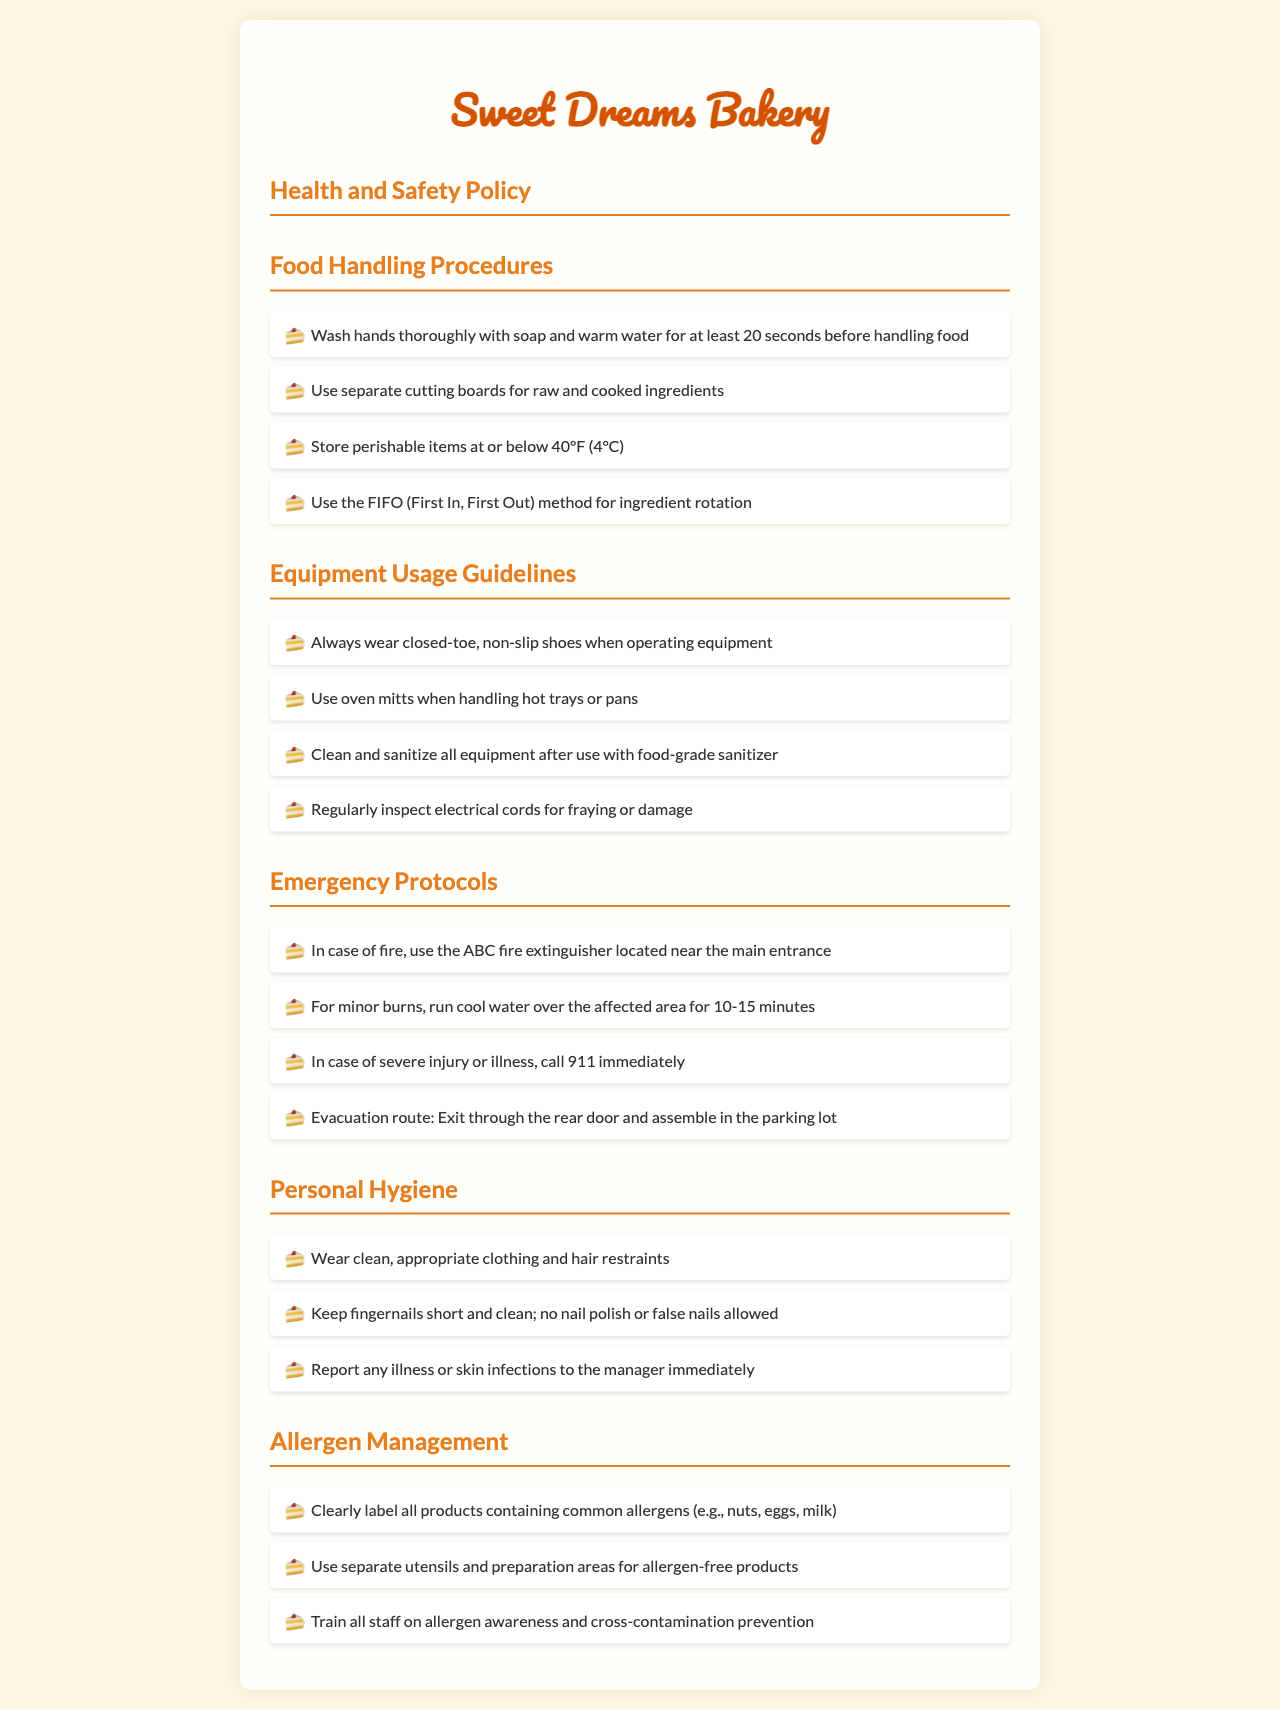what is the first step in food handling procedures? The document states that the first step in food handling procedures is to wash hands thoroughly with soap and warm water for at least 20 seconds before handling food.
Answer: wash hands thoroughly what is the evacuation route? The evacuation route provided in the document is to exit through the rear door and assemble in the parking lot.
Answer: rear door and parking lot what temperature should perishable items be stored at? The document indicates that perishable items should be stored at or below 40°F (4°C).
Answer: 40°F (4°C) what personal hygiene practice is required regarding fingernails? According to the document, fingernails should be kept short and clean; no nail polish or false nails allowed.
Answer: short and clean how should equipment be cleaned after use? The document specifies that all equipment should be cleaned and sanitized after use with food-grade sanitizer.
Answer: food-grade sanitizer what type of shoes should be worn when operating equipment? The document advises that closed-toe, non-slip shoes should be worn when operating equipment.
Answer: closed-toe, non-slip shoes what should be done in case of a severe injury or illness? The document states that in case of severe injury or illness, one should call 911 immediately.
Answer: call 911 which allergens need to be clearly labeled? The document mentions that products containing common allergens like nuts, eggs, and milk need to be clearly labeled.
Answer: nuts, eggs, milk what should be done for minor burns? For minor burns, the document states to run cool water over the affected area for 10-15 minutes.
Answer: cool water for 10-15 minutes 